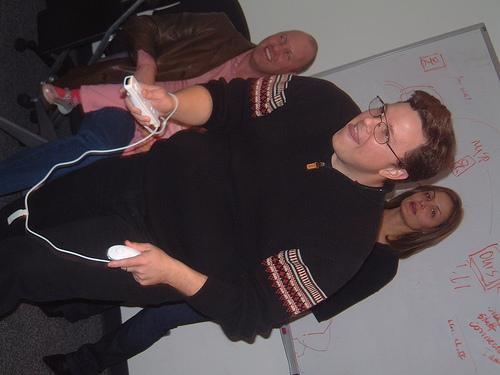How many players are there? one 